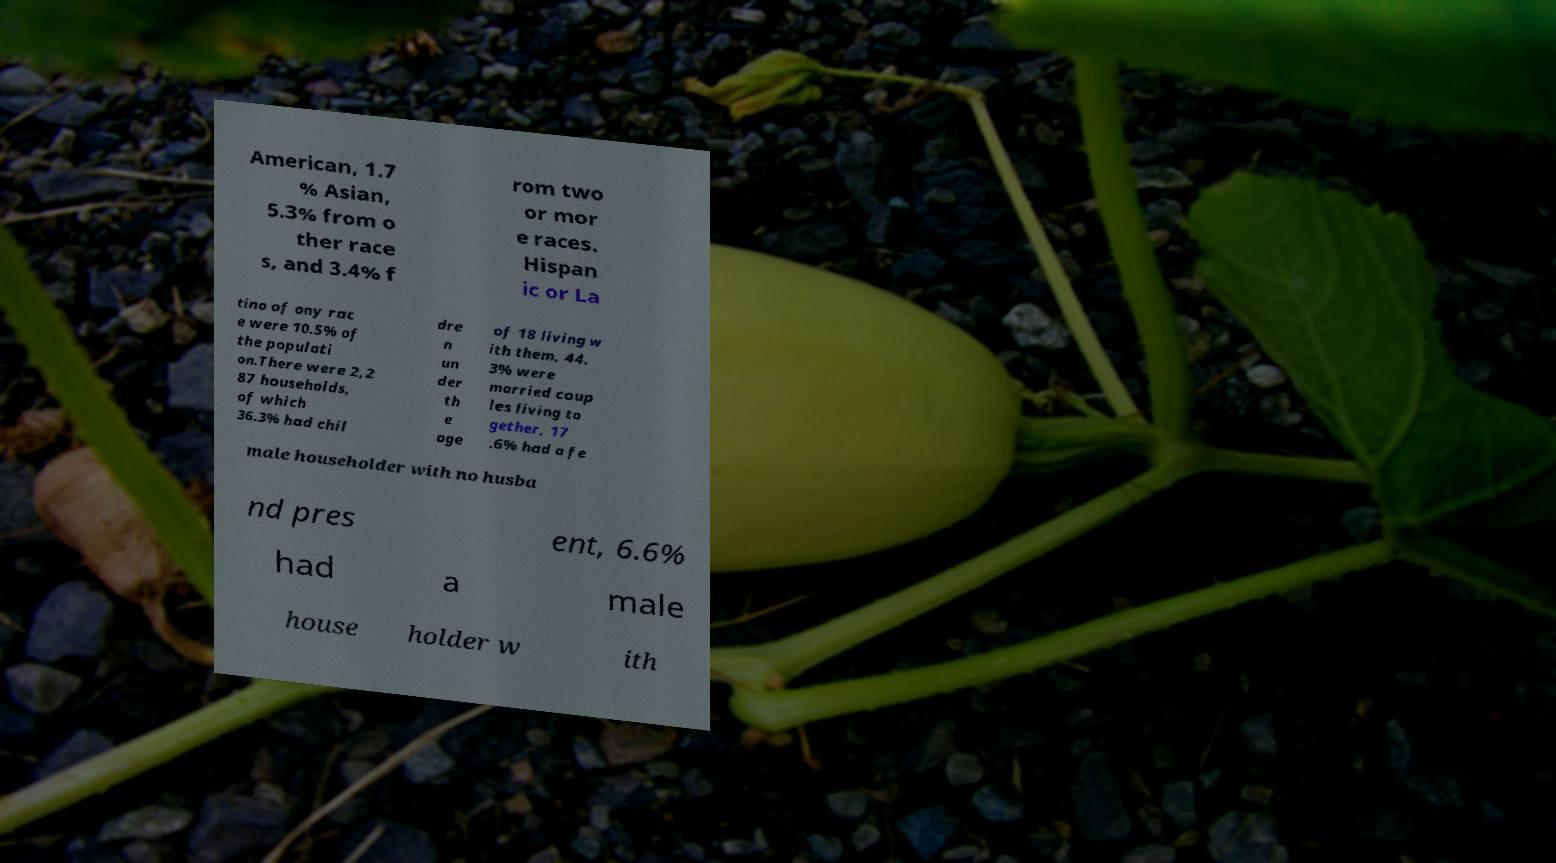Can you read and provide the text displayed in the image?This photo seems to have some interesting text. Can you extract and type it out for me? American, 1.7 % Asian, 5.3% from o ther race s, and 3.4% f rom two or mor e races. Hispan ic or La tino of any rac e were 10.5% of the populati on.There were 2,2 87 households, of which 36.3% had chil dre n un der th e age of 18 living w ith them, 44. 3% were married coup les living to gether, 17 .6% had a fe male householder with no husba nd pres ent, 6.6% had a male house holder w ith 